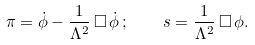Convert formula to latex. <formula><loc_0><loc_0><loc_500><loc_500>\pi = \dot { \phi } - \frac { 1 } { \Lambda ^ { 2 } } \, \square \, \dot { \phi } \, ; \quad s = \frac { 1 } { \Lambda ^ { 2 } } \, \square \, \phi .</formula> 